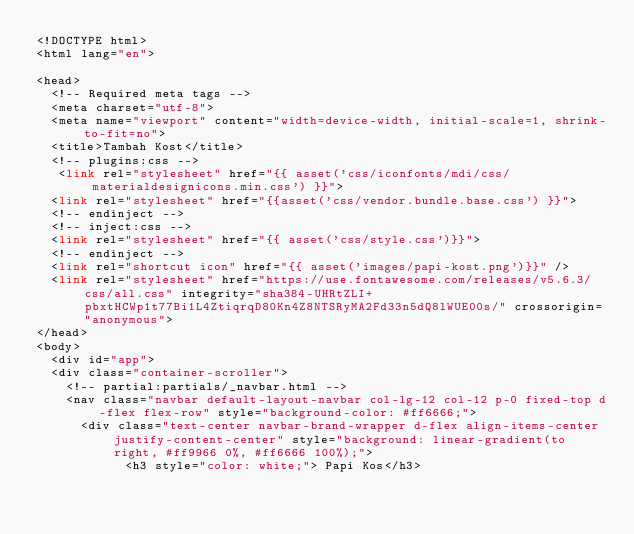<code> <loc_0><loc_0><loc_500><loc_500><_PHP_><!DOCTYPE html>
<html lang="en">

<head>
  <!-- Required meta tags -->
  <meta charset="utf-8">
  <meta name="viewport" content="width=device-width, initial-scale=1, shrink-to-fit=no">
  <title>Tambah Kost</title>
  <!-- plugins:css -->
   <link rel="stylesheet" href="{{ asset('css/iconfonts/mdi/css/materialdesignicons.min.css') }}">
  <link rel="stylesheet" href="{{asset('css/vendor.bundle.base.css') }}">
  <!-- endinject -->
  <!-- inject:css -->
  <link rel="stylesheet" href="{{ asset('css/style.css')}}">
  <!-- endinject -->
  <link rel="shortcut icon" href="{{ asset('images/papi-kost.png')}}" />
  <link rel="stylesheet" href="https://use.fontawesome.com/releases/v5.6.3/css/all.css" integrity="sha384-UHRtZLI+pbxtHCWp1t77Bi1L4ZtiqrqD80Kn4Z8NTSRyMA2Fd33n5dQ8lWUE00s/" crossorigin="anonymous">
</head>
<body>
  <div id="app">
  <div class="container-scroller">
    <!-- partial:partials/_navbar.html -->
    <nav class="navbar default-layout-navbar col-lg-12 col-12 p-0 fixed-top d-flex flex-row" style="background-color: #ff6666;">
      <div class="text-center navbar-brand-wrapper d-flex align-items-center justify-content-center" style="background: linear-gradient(to right, #ff9966 0%, #ff6666 100%);">
            <h3 style="color: white;"> Papi Kos</h3></code> 